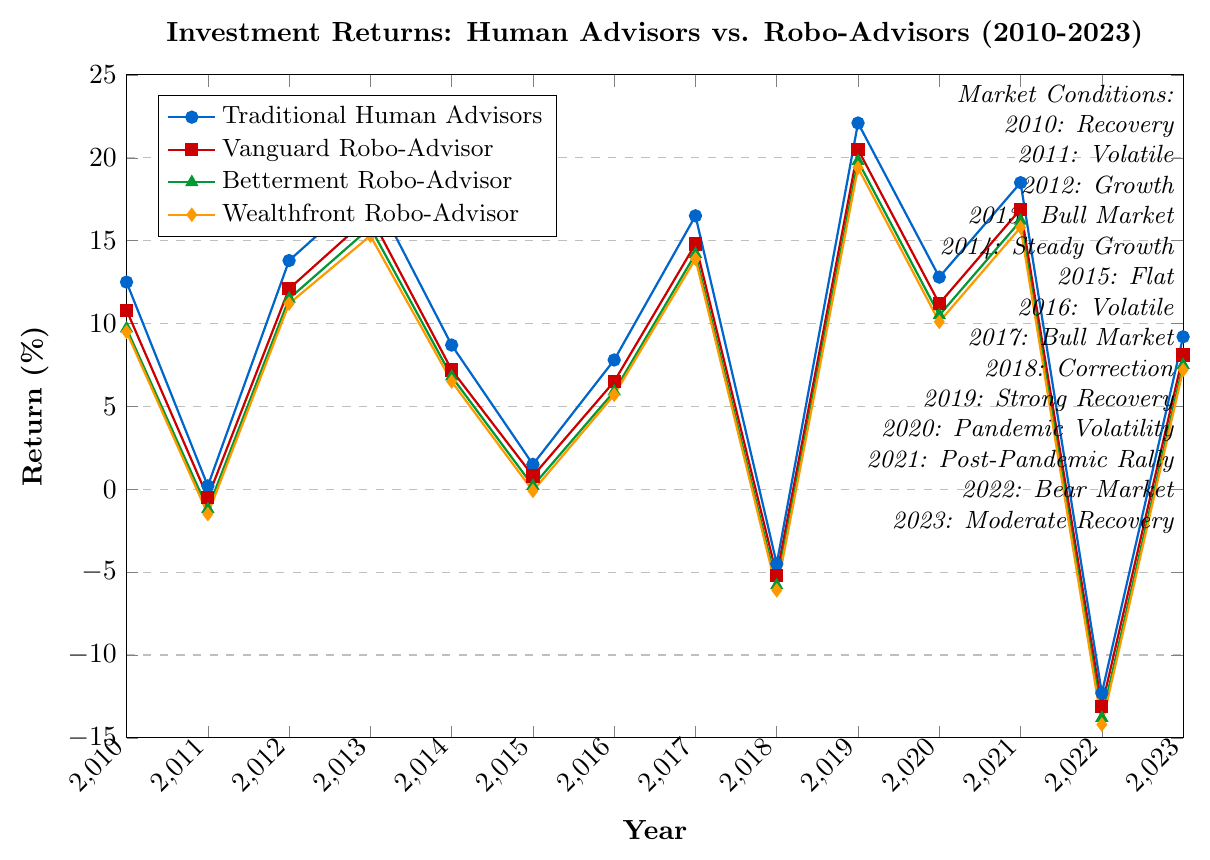What was the highest return achieved by Traditional Human Advisors, and in which year? The highest return by Traditional Human Advisors is observed in 2019 with a value of 22.1%. Skim through the line for Traditional Human Advisors to find the peak point and note the year.
Answer: 2019 Which investment advisor had the highest return in 2020? Evaluating the returns in the year 2020, the Traditional Human Advisors had the highest return of 12.8%. Compare the values for all advisors for the year 2020.
Answer: Traditional Human Advisors During Bear Market periods, which type of advisor showed the lowest return? In 2022, and during Bear Market conditions, Wealthfront Robo-Advisor had the lowest return with a value of -14.2%. Locate the Bear Market period and compare the returns of all advisors.
Answer: Wealthfront Robo-Advisor How did Vanguard Robo-Advisor perform in the Post-Pandemic Rally compared to Betterment Robo-Advisor? In 2021, the Post-Pandemic Rally year, Vanguard Robo-Advisor had a return of 16.9% while Betterment Robo-Advisor had a 16.2% return. Compare the data points for both advisors in 2021.
Answer: Vanguard Robo-Advisor had a higher return Calculate the average return of Wealthfront Robo-Advisor over the entire period. Add up all the Wealthfront Robo-Advisor returns from 2010 to 2023 then divide by the number of years (14). (9.5 - 1.5 + 11.2 + 15.3 + 6.5 - 0.1 + 5.7 + 13.9 - 6.1 + 19.4 + 10.1 + 15.8 - 14.2 + 7.2) / 14 = 6.66%
Answer: 6.66% Which advisor demonstrated the most consistent performance (lowest return variability) over the 14 years? Calculate the standard deviation of returns for each advisor. The advisor with the smallest standard deviation has the least variability. Traditional Human Advisors show the most consistent performance.
Answer: Traditional Human Advisors Compare the returns in Volatile market conditions for Traditional Human Advisors and Wealthfront Robo-Advisor. Which one had better returns, on average? For 2011 and 2016, the average returns are calculated for both. Traditional Human Advisors: (0.2 + 7.8)/2 = 4%, Wealthfront Robo-Advisor: (-1.5 + 5.7)/2 = 2.1%. Traditional Human Advisors had better average returns.
Answer: Traditional Human Advisors Which year saw the largest drop in returns for Traditional Human Advisors? Identify the year-by-year differences for Traditional Human Advisors' returns and find the largest negative value, occurring from 2021 to 2022 with a drop of (18.5 - (-12.3)) = 30.8%.
Answer: 2022 During Steady Growth market conditions, who performed worse: Betterment Robo-Advisor or Wealthfront Robo-Advisor? In 2014, during Steady Growth conditions, Betterment Robo-Advisor returned 6.8% while Wealthfront Robo-Advisor had 6.5%. Wealthfront performed worse. Compare the returns for both advisors in 2014.
Answer: Wealthfront Robo-Advisor 